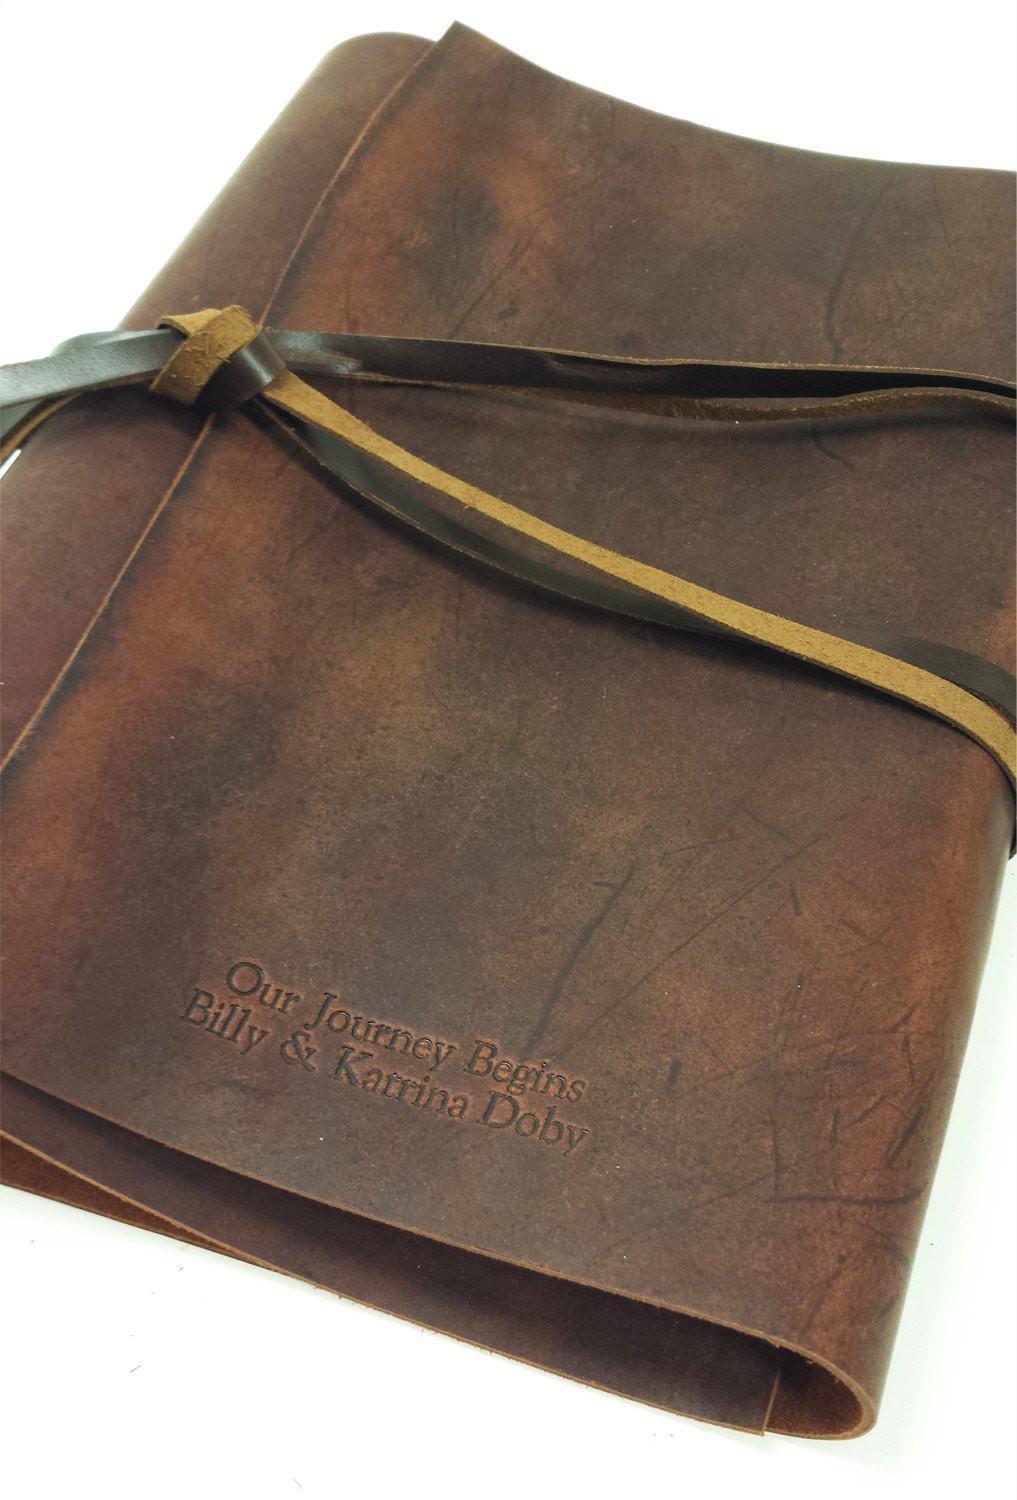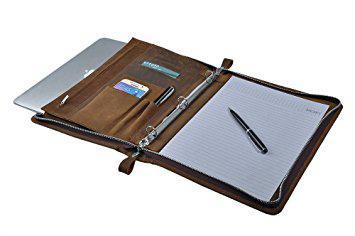The first image is the image on the left, the second image is the image on the right. Given the left and right images, does the statement "Both binders are against a white background." hold true? Answer yes or no. Yes. The first image is the image on the left, the second image is the image on the right. Considering the images on both sides, is "Each image contains a single brown binder" valid? Answer yes or no. Yes. 